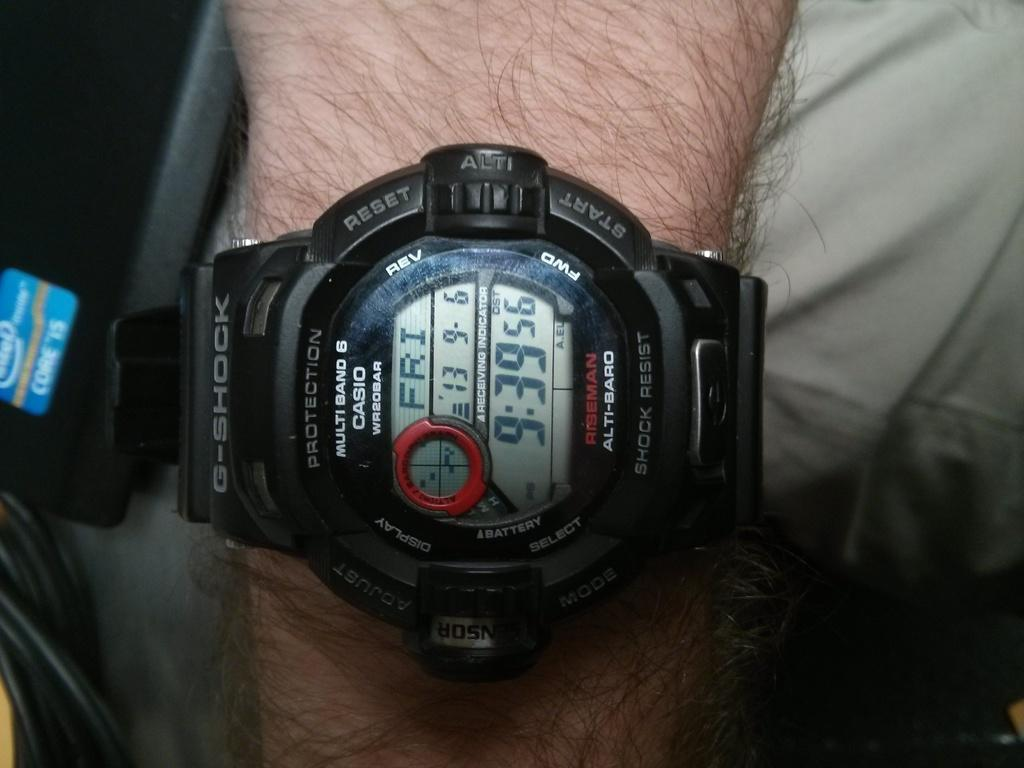<image>
Give a short and clear explanation of the subsequent image. G Shock black and red watch that contains the date and time 